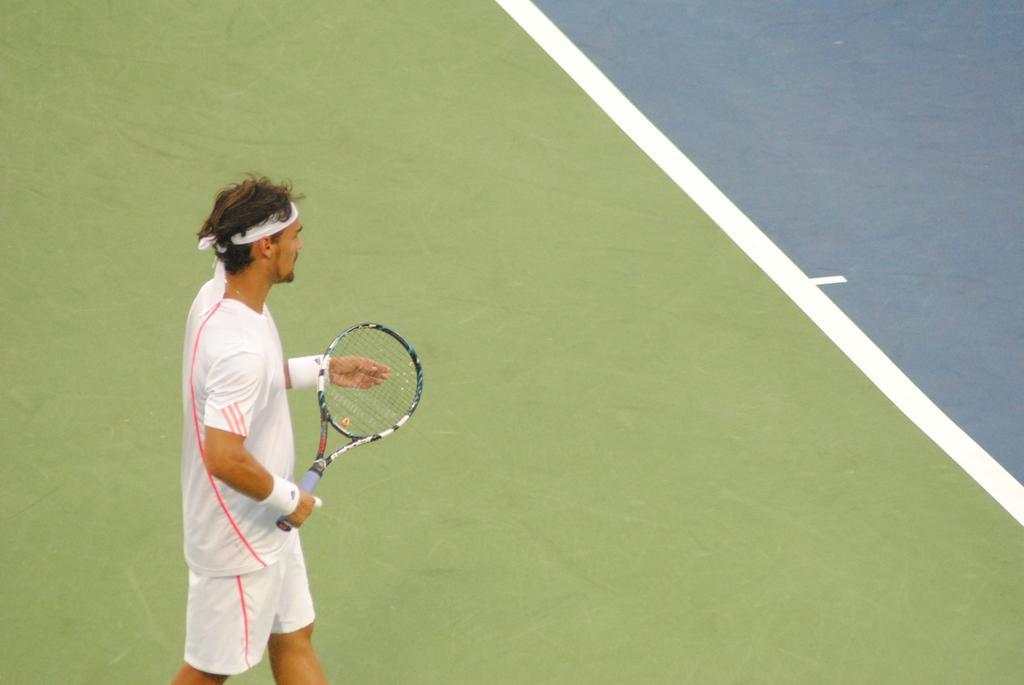How would you summarize this image in a sentence or two? In this image we can see a man standing and holding a racket. In the background there is a ground. 